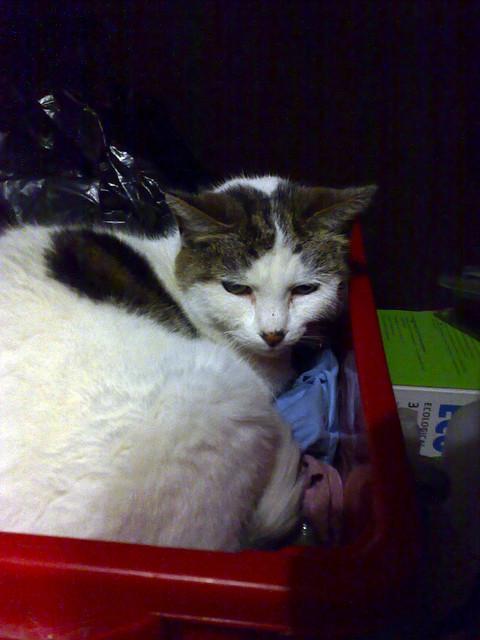How many people aren't holding their phone?
Give a very brief answer. 0. 